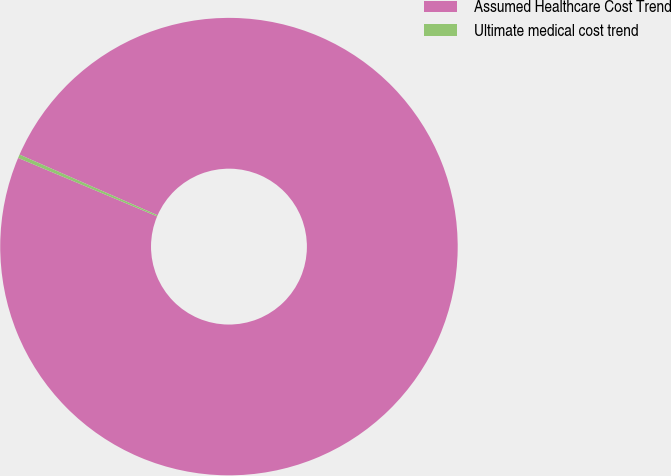<chart> <loc_0><loc_0><loc_500><loc_500><pie_chart><fcel>Assumed Healthcare Cost Trend<fcel>Ultimate medical cost trend<nl><fcel>99.75%<fcel>0.25%<nl></chart> 